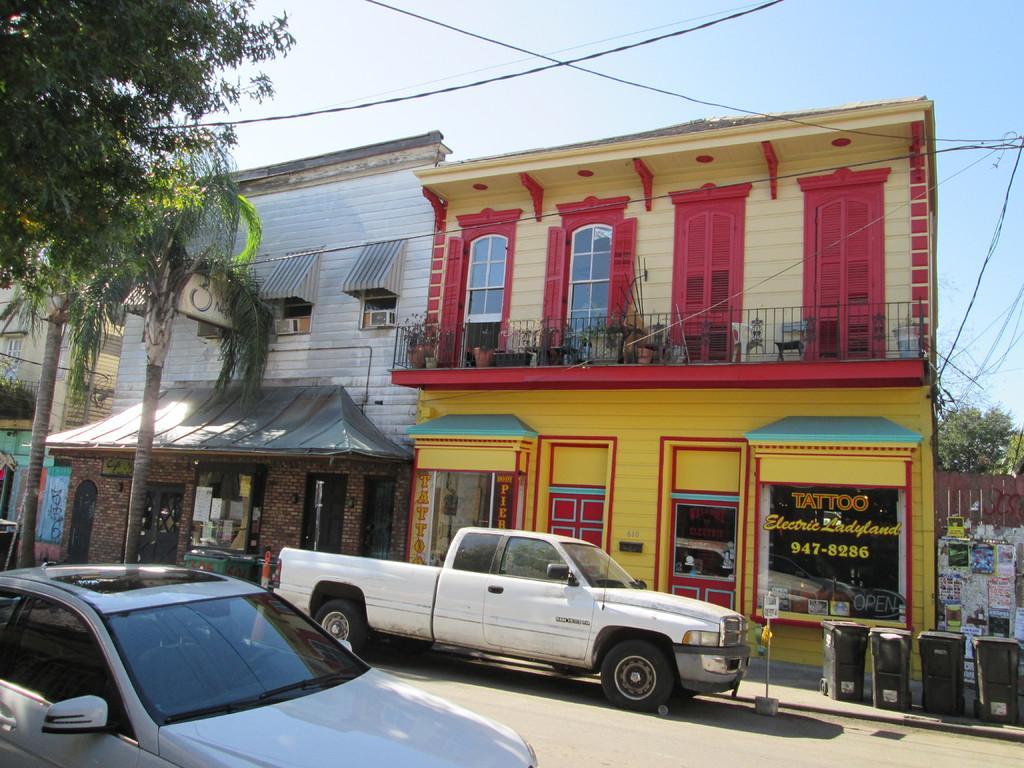Describe this image in one or two sentences. This image is clicked on the road. There are many vehicles moving on the road. Beside the road there is a walkway. There are dustbins on the walkway. In the background there are houses. There are posters and text on the houses. There are trees in the image. At the top there is the sky. There are cable wires in the air. 